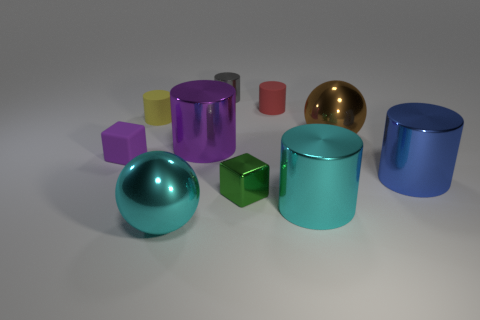There is a big object that is the same color as the tiny matte block; what shape is it?
Offer a terse response. Cylinder. What number of things are small red matte cubes or metal things in front of the purple cube?
Provide a short and direct response. 4. There is a cylinder that is in front of the tiny green shiny thing; what is its size?
Your answer should be very brief. Large. Is the number of cyan spheres that are to the right of the red matte cylinder less than the number of large metal spheres behind the yellow matte cylinder?
Offer a very short reply. No. There is a large object that is both in front of the purple cylinder and to the left of the small gray metallic object; what material is it?
Give a very brief answer. Metal. What shape is the gray object behind the block in front of the blue cylinder?
Your answer should be compact. Cylinder. What number of brown objects are rubber spheres or shiny things?
Offer a terse response. 1. There is a tiny red cylinder; are there any gray shiny things on the right side of it?
Offer a very short reply. No. The green metal object has what size?
Provide a succinct answer. Small. There is a yellow matte thing that is the same shape as the tiny red rubber thing; what size is it?
Provide a succinct answer. Small. 